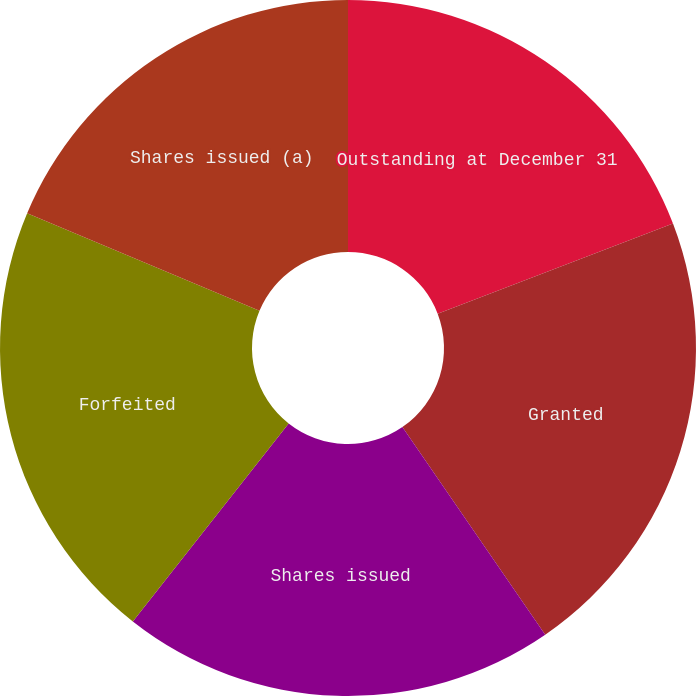<chart> <loc_0><loc_0><loc_500><loc_500><pie_chart><fcel>Outstanding at December 31<fcel>Granted<fcel>Shares issued<fcel>Forfeited<fcel>Shares issued (a)<nl><fcel>19.18%<fcel>21.23%<fcel>20.2%<fcel>20.72%<fcel>18.67%<nl></chart> 